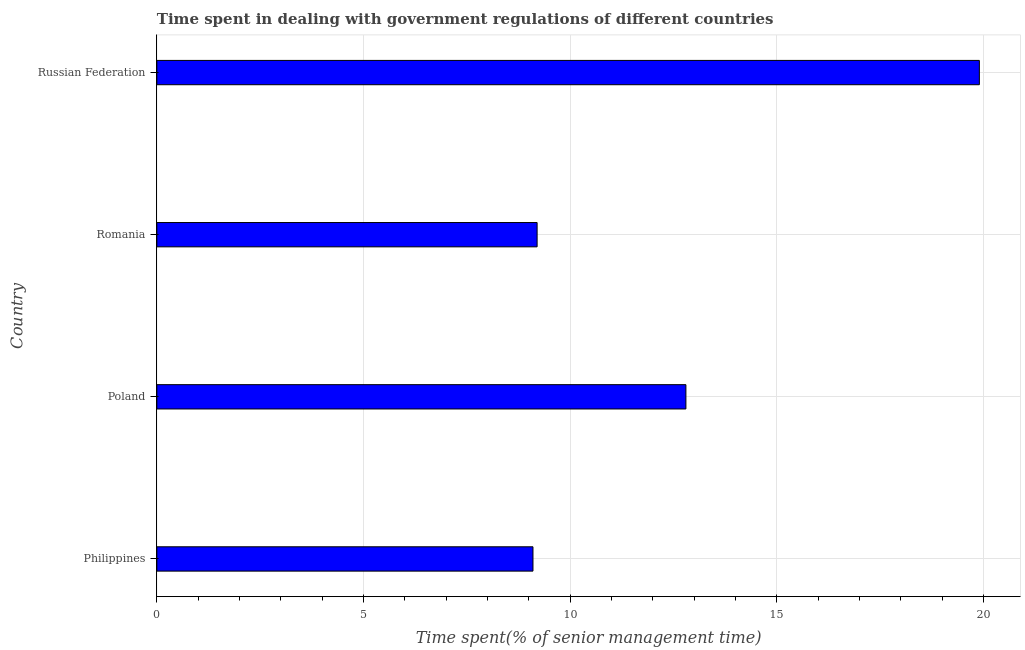Does the graph contain grids?
Give a very brief answer. Yes. What is the title of the graph?
Give a very brief answer. Time spent in dealing with government regulations of different countries. What is the label or title of the X-axis?
Make the answer very short. Time spent(% of senior management time). What is the label or title of the Y-axis?
Keep it short and to the point. Country. In which country was the time spent in dealing with government regulations maximum?
Your response must be concise. Russian Federation. In which country was the time spent in dealing with government regulations minimum?
Ensure brevity in your answer.  Philippines. What is the sum of the time spent in dealing with government regulations?
Provide a short and direct response. 51. What is the average time spent in dealing with government regulations per country?
Ensure brevity in your answer.  12.75. What is the median time spent in dealing with government regulations?
Provide a succinct answer. 11. What is the ratio of the time spent in dealing with government regulations in Poland to that in Russian Federation?
Ensure brevity in your answer.  0.64. Is the time spent in dealing with government regulations in Philippines less than that in Romania?
Ensure brevity in your answer.  Yes. What is the difference between the highest and the second highest time spent in dealing with government regulations?
Keep it short and to the point. 7.1. Is the sum of the time spent in dealing with government regulations in Philippines and Romania greater than the maximum time spent in dealing with government regulations across all countries?
Offer a terse response. No. How many bars are there?
Ensure brevity in your answer.  4. Are all the bars in the graph horizontal?
Give a very brief answer. Yes. How many countries are there in the graph?
Offer a very short reply. 4. What is the difference between two consecutive major ticks on the X-axis?
Keep it short and to the point. 5. Are the values on the major ticks of X-axis written in scientific E-notation?
Provide a short and direct response. No. What is the Time spent(% of senior management time) in Russian Federation?
Offer a very short reply. 19.9. What is the difference between the Time spent(% of senior management time) in Philippines and Poland?
Make the answer very short. -3.7. What is the difference between the Time spent(% of senior management time) in Philippines and Romania?
Your answer should be very brief. -0.1. What is the difference between the Time spent(% of senior management time) in Philippines and Russian Federation?
Offer a very short reply. -10.8. What is the difference between the Time spent(% of senior management time) in Poland and Russian Federation?
Keep it short and to the point. -7.1. What is the ratio of the Time spent(% of senior management time) in Philippines to that in Poland?
Your answer should be compact. 0.71. What is the ratio of the Time spent(% of senior management time) in Philippines to that in Russian Federation?
Keep it short and to the point. 0.46. What is the ratio of the Time spent(% of senior management time) in Poland to that in Romania?
Keep it short and to the point. 1.39. What is the ratio of the Time spent(% of senior management time) in Poland to that in Russian Federation?
Provide a succinct answer. 0.64. What is the ratio of the Time spent(% of senior management time) in Romania to that in Russian Federation?
Offer a very short reply. 0.46. 